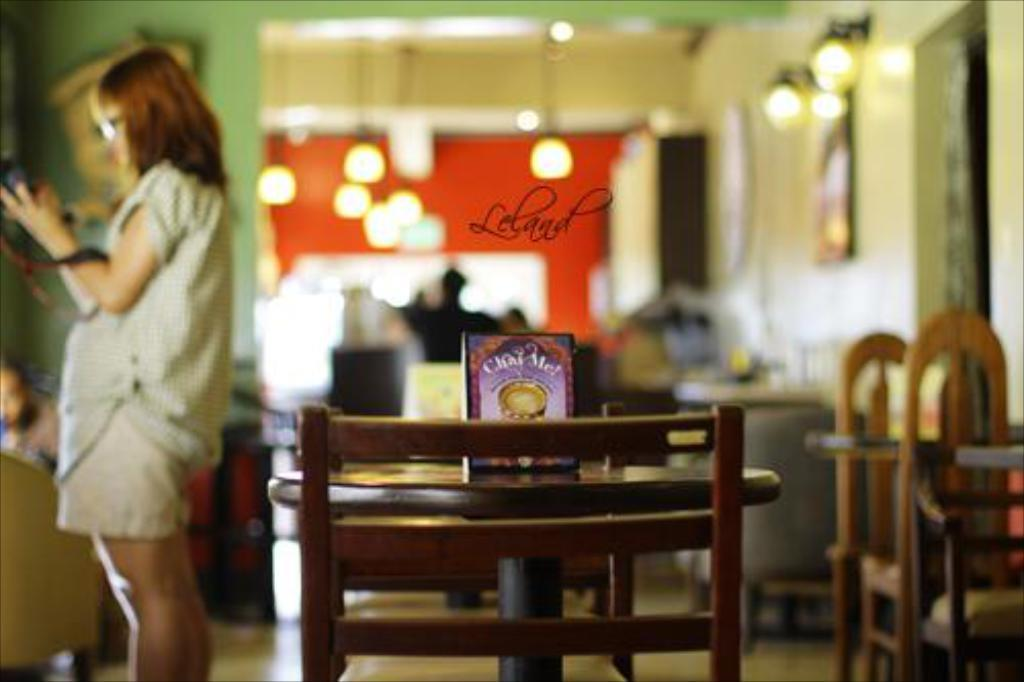What piece of furniture is present in the image? There is a table in the image. Can you describe the person in the image? There is a person standing at the left side of the image. What type of book is the person reading in the image? There is no book present in the image; the person is standing at the left side of the image. Can you describe the grass in the image? There is no grass present in the image; it features a table and a person standing at the left side. 